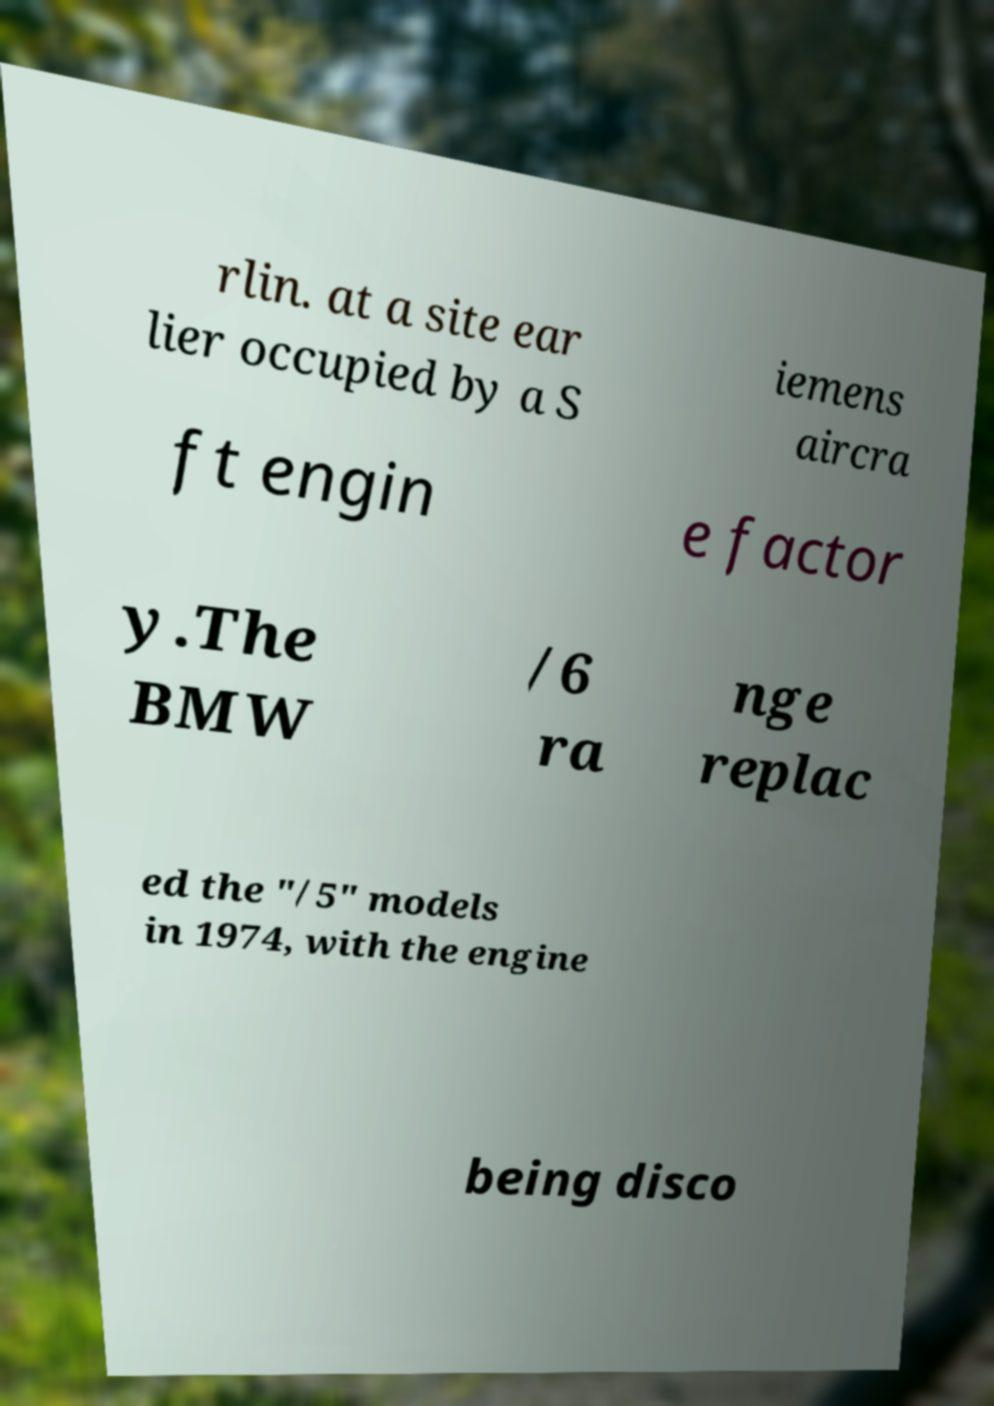Could you assist in decoding the text presented in this image and type it out clearly? rlin. at a site ear lier occupied by a S iemens aircra ft engin e factor y.The BMW /6 ra nge replac ed the "/5" models in 1974, with the engine being disco 